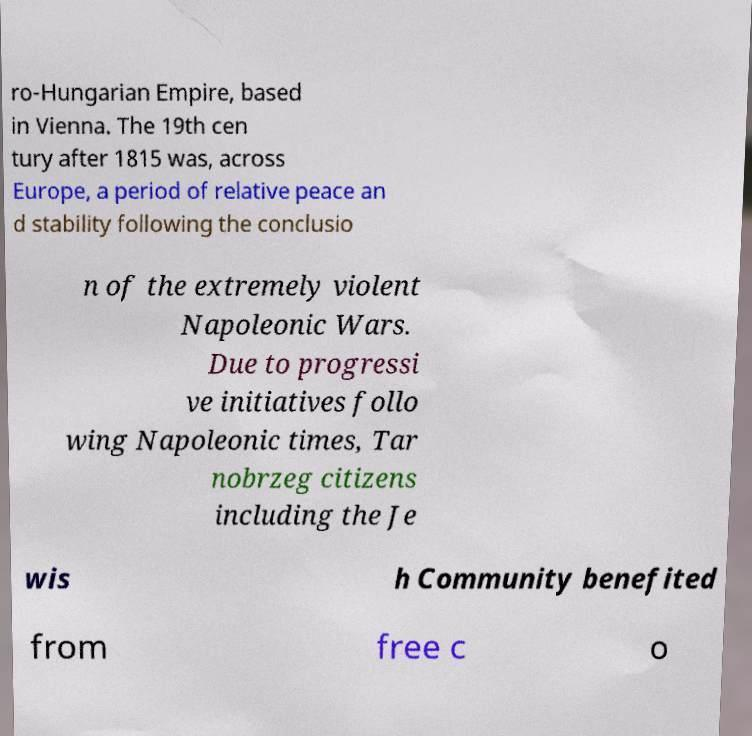Please identify and transcribe the text found in this image. ro-Hungarian Empire, based in Vienna. The 19th cen tury after 1815 was, across Europe, a period of relative peace an d stability following the conclusio n of the extremely violent Napoleonic Wars. Due to progressi ve initiatives follo wing Napoleonic times, Tar nobrzeg citizens including the Je wis h Community benefited from free c o 